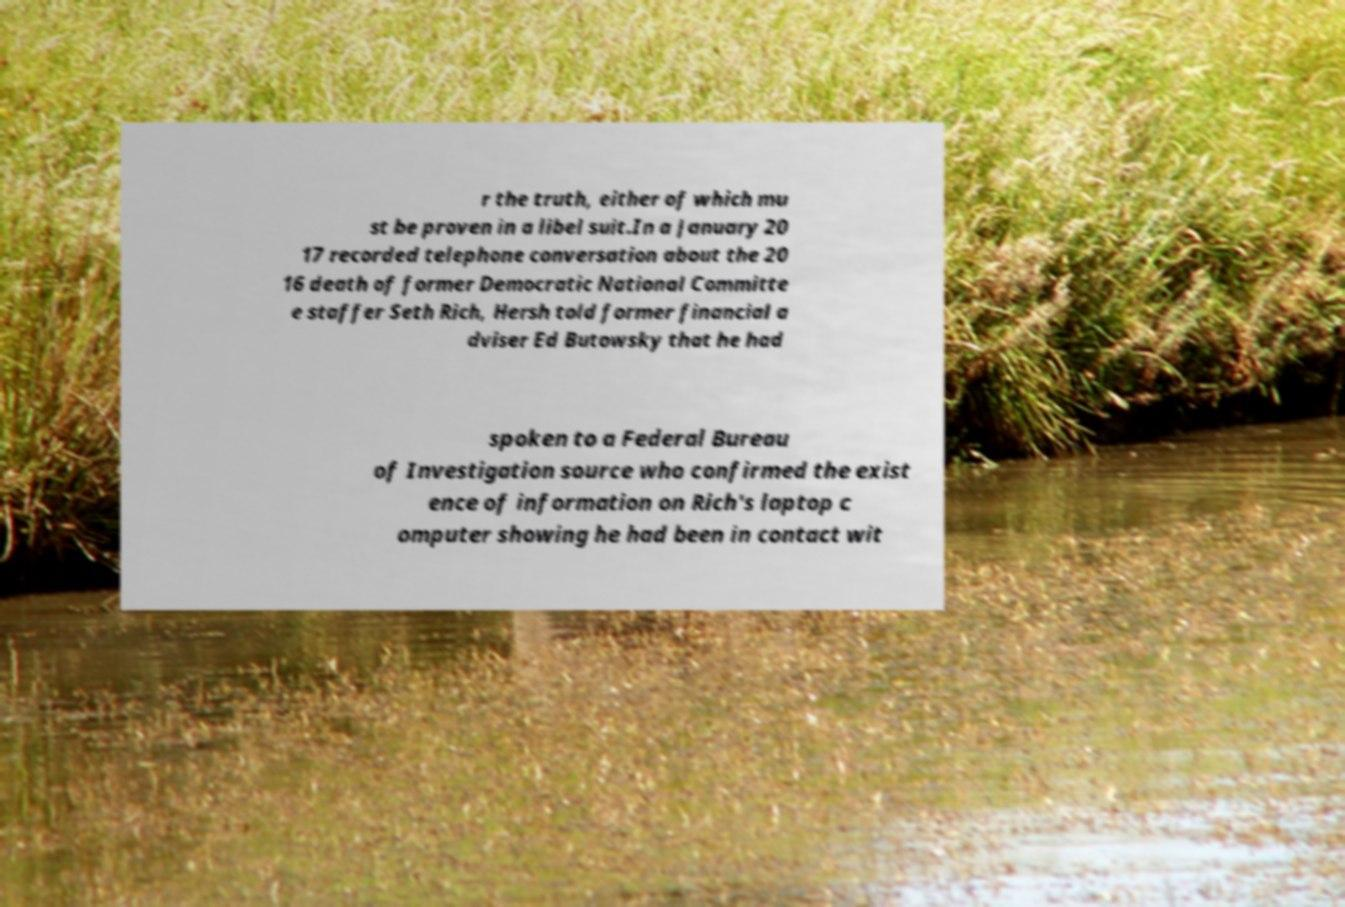For documentation purposes, I need the text within this image transcribed. Could you provide that? r the truth, either of which mu st be proven in a libel suit.In a January 20 17 recorded telephone conversation about the 20 16 death of former Democratic National Committe e staffer Seth Rich, Hersh told former financial a dviser Ed Butowsky that he had spoken to a Federal Bureau of Investigation source who confirmed the exist ence of information on Rich's laptop c omputer showing he had been in contact wit 